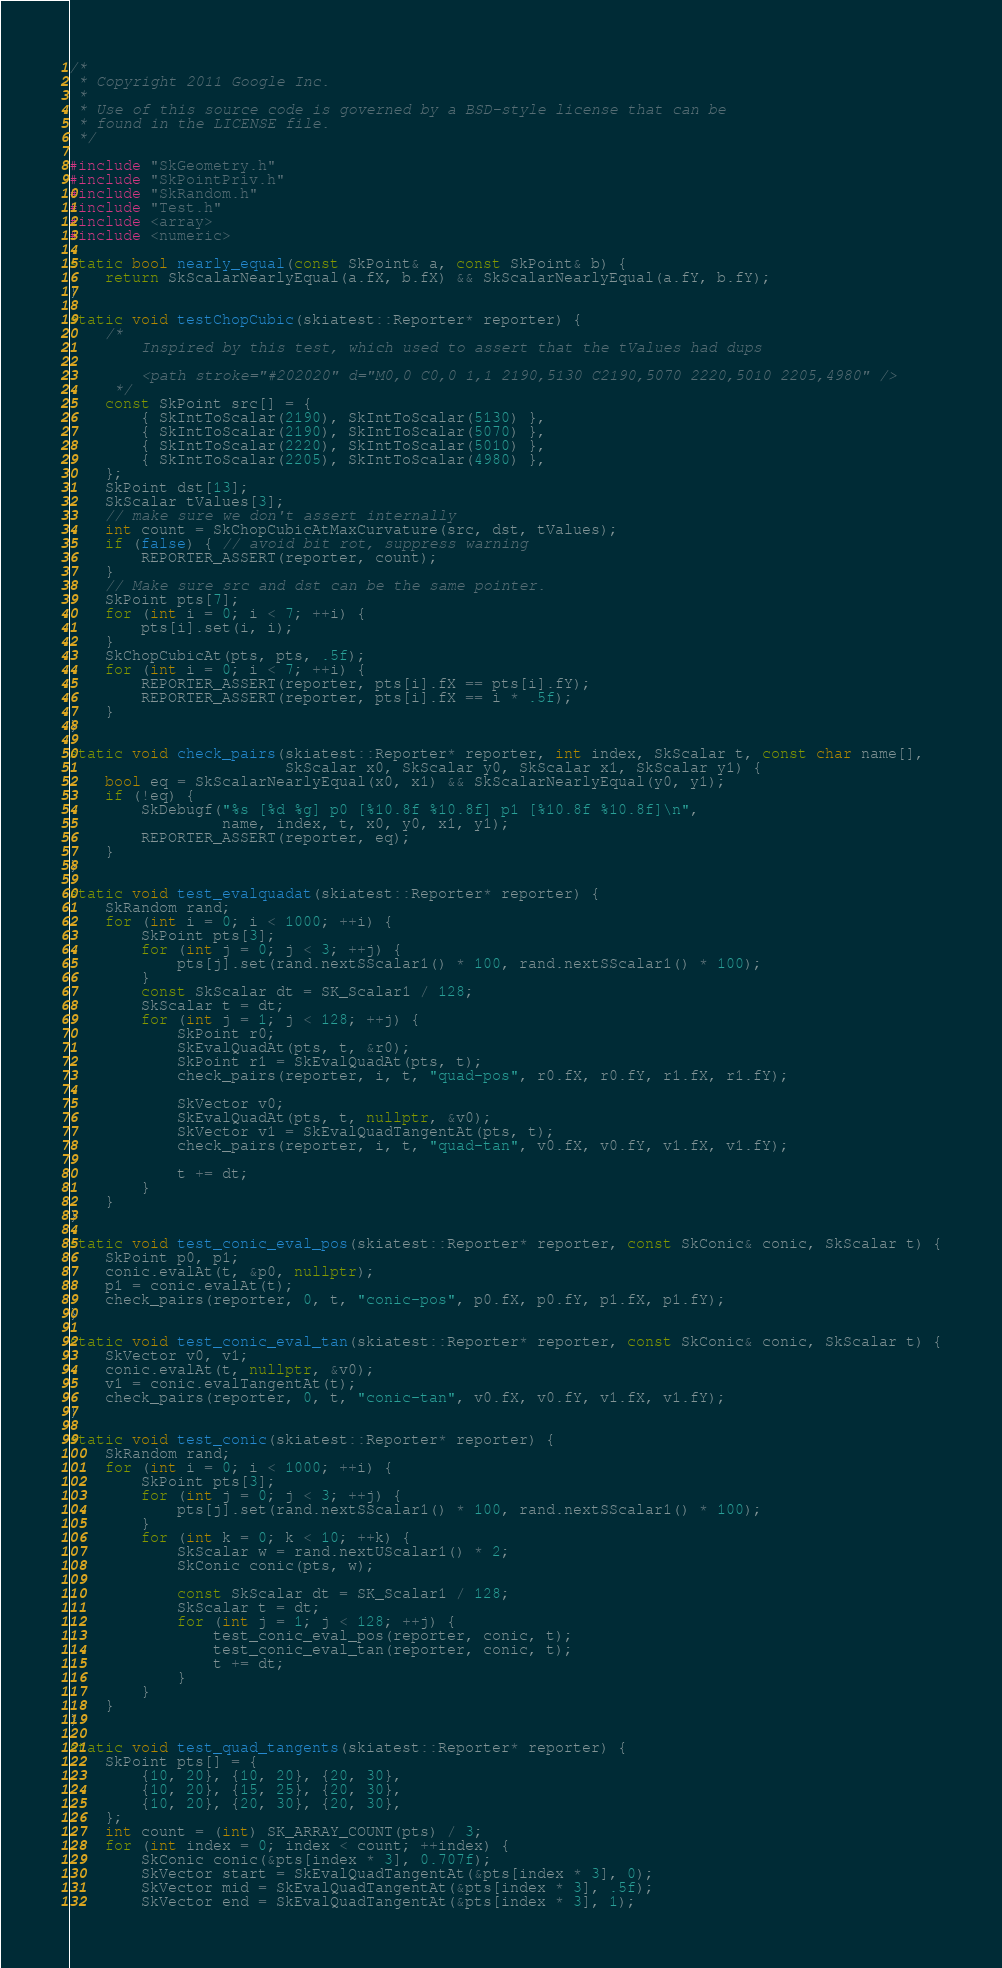Convert code to text. <code><loc_0><loc_0><loc_500><loc_500><_C++_>/*
 * Copyright 2011 Google Inc.
 *
 * Use of this source code is governed by a BSD-style license that can be
 * found in the LICENSE file.
 */

#include "SkGeometry.h"
#include "SkPointPriv.h"
#include "SkRandom.h"
#include "Test.h"
#include <array>
#include <numeric>

static bool nearly_equal(const SkPoint& a, const SkPoint& b) {
    return SkScalarNearlyEqual(a.fX, b.fX) && SkScalarNearlyEqual(a.fY, b.fY);
}

static void testChopCubic(skiatest::Reporter* reporter) {
    /*
        Inspired by this test, which used to assert that the tValues had dups

        <path stroke="#202020" d="M0,0 C0,0 1,1 2190,5130 C2190,5070 2220,5010 2205,4980" />
     */
    const SkPoint src[] = {
        { SkIntToScalar(2190), SkIntToScalar(5130) },
        { SkIntToScalar(2190), SkIntToScalar(5070) },
        { SkIntToScalar(2220), SkIntToScalar(5010) },
        { SkIntToScalar(2205), SkIntToScalar(4980) },
    };
    SkPoint dst[13];
    SkScalar tValues[3];
    // make sure we don't assert internally
    int count = SkChopCubicAtMaxCurvature(src, dst, tValues);
    if (false) { // avoid bit rot, suppress warning
        REPORTER_ASSERT(reporter, count);
    }
    // Make sure src and dst can be the same pointer.
    SkPoint pts[7];
    for (int i = 0; i < 7; ++i) {
        pts[i].set(i, i);
    }
    SkChopCubicAt(pts, pts, .5f);
    for (int i = 0; i < 7; ++i) {
        REPORTER_ASSERT(reporter, pts[i].fX == pts[i].fY);
        REPORTER_ASSERT(reporter, pts[i].fX == i * .5f);
    }
}

static void check_pairs(skiatest::Reporter* reporter, int index, SkScalar t, const char name[],
                        SkScalar x0, SkScalar y0, SkScalar x1, SkScalar y1) {
    bool eq = SkScalarNearlyEqual(x0, x1) && SkScalarNearlyEqual(y0, y1);
    if (!eq) {
        SkDebugf("%s [%d %g] p0 [%10.8f %10.8f] p1 [%10.8f %10.8f]\n",
                 name, index, t, x0, y0, x1, y1);
        REPORTER_ASSERT(reporter, eq);
    }
}

static void test_evalquadat(skiatest::Reporter* reporter) {
    SkRandom rand;
    for (int i = 0; i < 1000; ++i) {
        SkPoint pts[3];
        for (int j = 0; j < 3; ++j) {
            pts[j].set(rand.nextSScalar1() * 100, rand.nextSScalar1() * 100);
        }
        const SkScalar dt = SK_Scalar1 / 128;
        SkScalar t = dt;
        for (int j = 1; j < 128; ++j) {
            SkPoint r0;
            SkEvalQuadAt(pts, t, &r0);
            SkPoint r1 = SkEvalQuadAt(pts, t);
            check_pairs(reporter, i, t, "quad-pos", r0.fX, r0.fY, r1.fX, r1.fY);

            SkVector v0;
            SkEvalQuadAt(pts, t, nullptr, &v0);
            SkVector v1 = SkEvalQuadTangentAt(pts, t);
            check_pairs(reporter, i, t, "quad-tan", v0.fX, v0.fY, v1.fX, v1.fY);

            t += dt;
        }
    }
}

static void test_conic_eval_pos(skiatest::Reporter* reporter, const SkConic& conic, SkScalar t) {
    SkPoint p0, p1;
    conic.evalAt(t, &p0, nullptr);
    p1 = conic.evalAt(t);
    check_pairs(reporter, 0, t, "conic-pos", p0.fX, p0.fY, p1.fX, p1.fY);
}

static void test_conic_eval_tan(skiatest::Reporter* reporter, const SkConic& conic, SkScalar t) {
    SkVector v0, v1;
    conic.evalAt(t, nullptr, &v0);
    v1 = conic.evalTangentAt(t);
    check_pairs(reporter, 0, t, "conic-tan", v0.fX, v0.fY, v1.fX, v1.fY);
}

static void test_conic(skiatest::Reporter* reporter) {
    SkRandom rand;
    for (int i = 0; i < 1000; ++i) {
        SkPoint pts[3];
        for (int j = 0; j < 3; ++j) {
            pts[j].set(rand.nextSScalar1() * 100, rand.nextSScalar1() * 100);
        }
        for (int k = 0; k < 10; ++k) {
            SkScalar w = rand.nextUScalar1() * 2;
            SkConic conic(pts, w);

            const SkScalar dt = SK_Scalar1 / 128;
            SkScalar t = dt;
            for (int j = 1; j < 128; ++j) {
                test_conic_eval_pos(reporter, conic, t);
                test_conic_eval_tan(reporter, conic, t);
                t += dt;
            }
        }
    }
}

static void test_quad_tangents(skiatest::Reporter* reporter) {
    SkPoint pts[] = {
        {10, 20}, {10, 20}, {20, 30},
        {10, 20}, {15, 25}, {20, 30},
        {10, 20}, {20, 30}, {20, 30},
    };
    int count = (int) SK_ARRAY_COUNT(pts) / 3;
    for (int index = 0; index < count; ++index) {
        SkConic conic(&pts[index * 3], 0.707f);
        SkVector start = SkEvalQuadTangentAt(&pts[index * 3], 0);
        SkVector mid = SkEvalQuadTangentAt(&pts[index * 3], .5f);
        SkVector end = SkEvalQuadTangentAt(&pts[index * 3], 1);</code> 